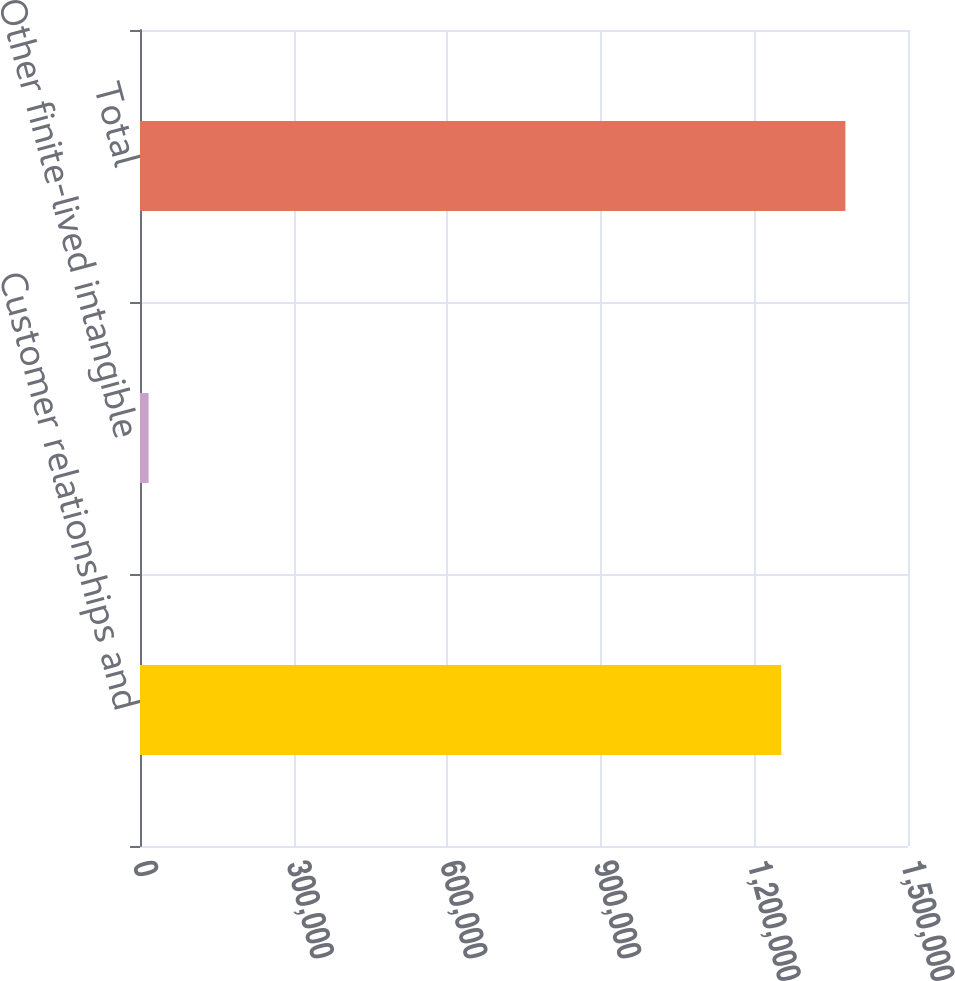Convert chart to OTSL. <chart><loc_0><loc_0><loc_500><loc_500><bar_chart><fcel>Customer relationships and<fcel>Other finite-lived intangible<fcel>Total<nl><fcel>1.25252e+06<fcel>16799<fcel>1.37778e+06<nl></chart> 